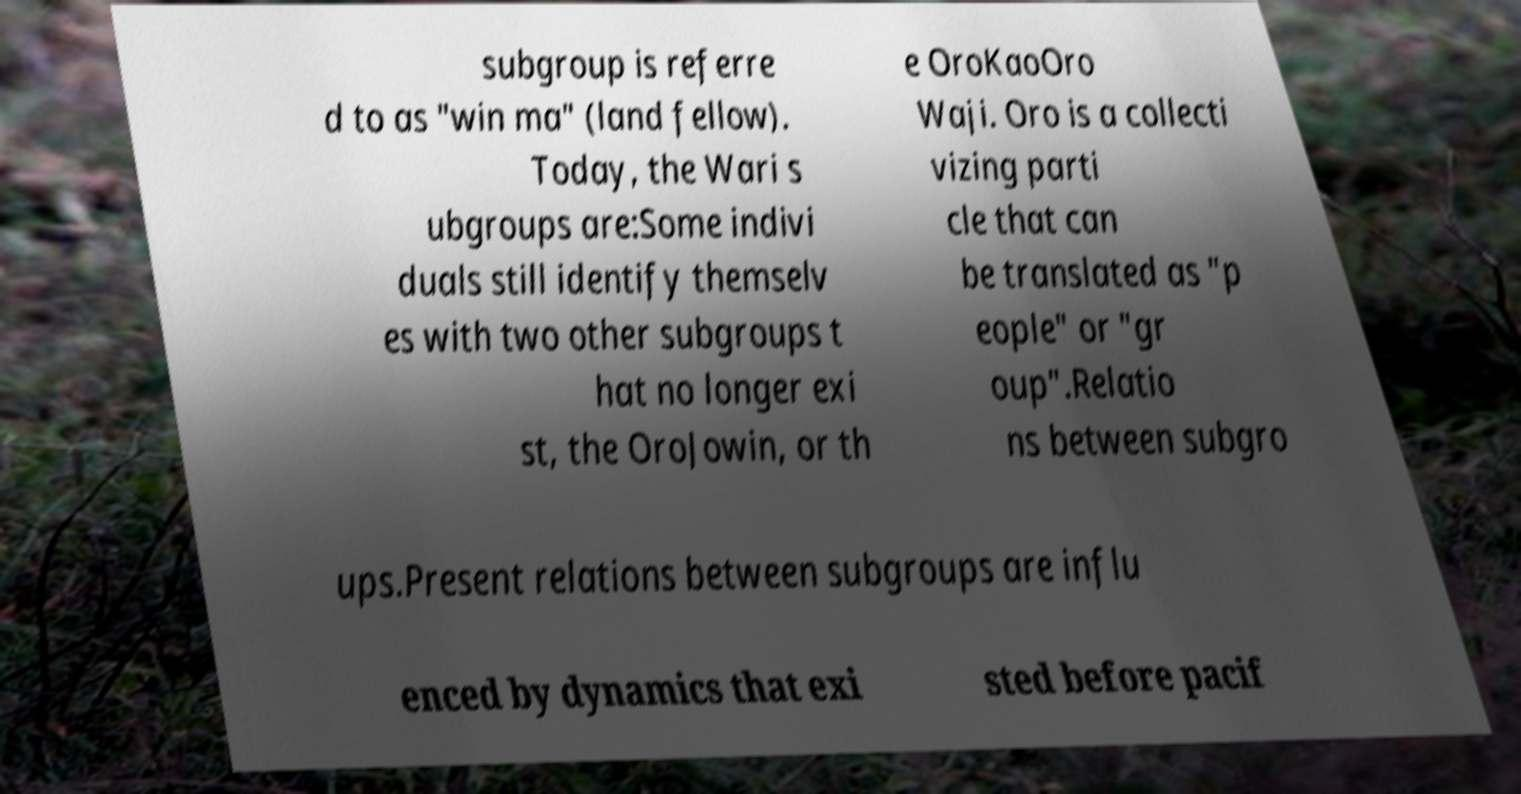Can you accurately transcribe the text from the provided image for me? subgroup is referre d to as "win ma" (land fellow). Today, the Wari s ubgroups are:Some indivi duals still identify themselv es with two other subgroups t hat no longer exi st, the OroJowin, or th e OroKaoOro Waji. Oro is a collecti vizing parti cle that can be translated as "p eople" or "gr oup".Relatio ns between subgro ups.Present relations between subgroups are influ enced by dynamics that exi sted before pacif 